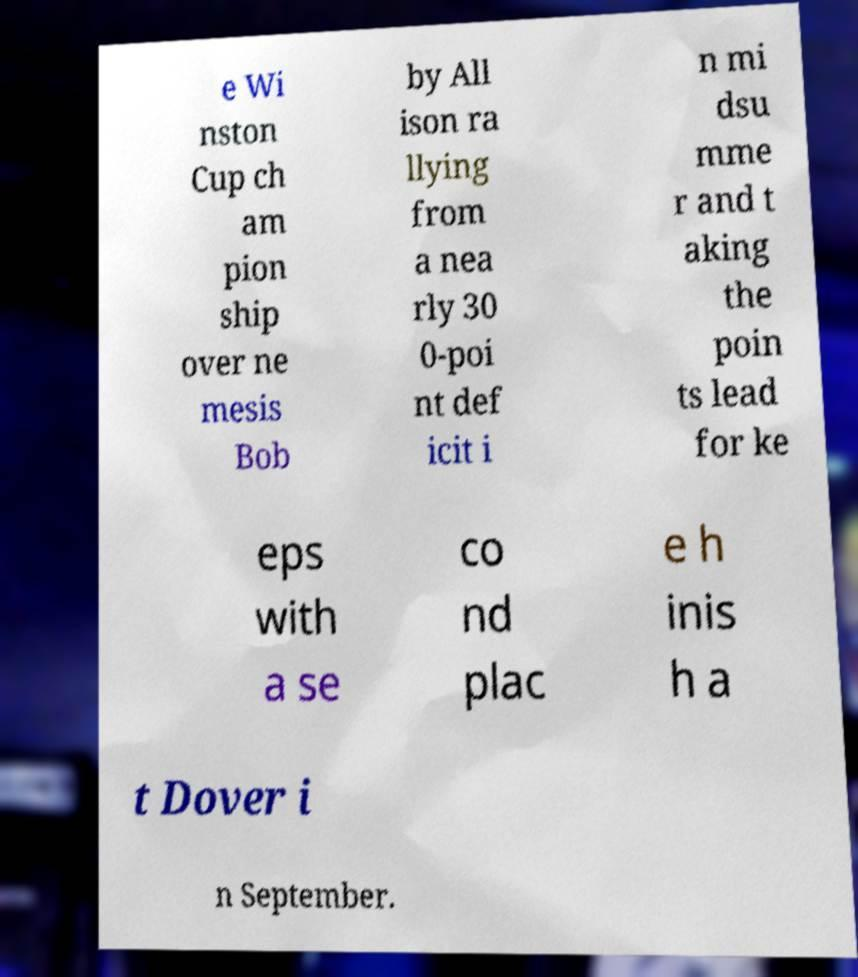Please identify and transcribe the text found in this image. e Wi nston Cup ch am pion ship over ne mesis Bob by All ison ra llying from a nea rly 30 0-poi nt def icit i n mi dsu mme r and t aking the poin ts lead for ke eps with a se co nd plac e h inis h a t Dover i n September. 